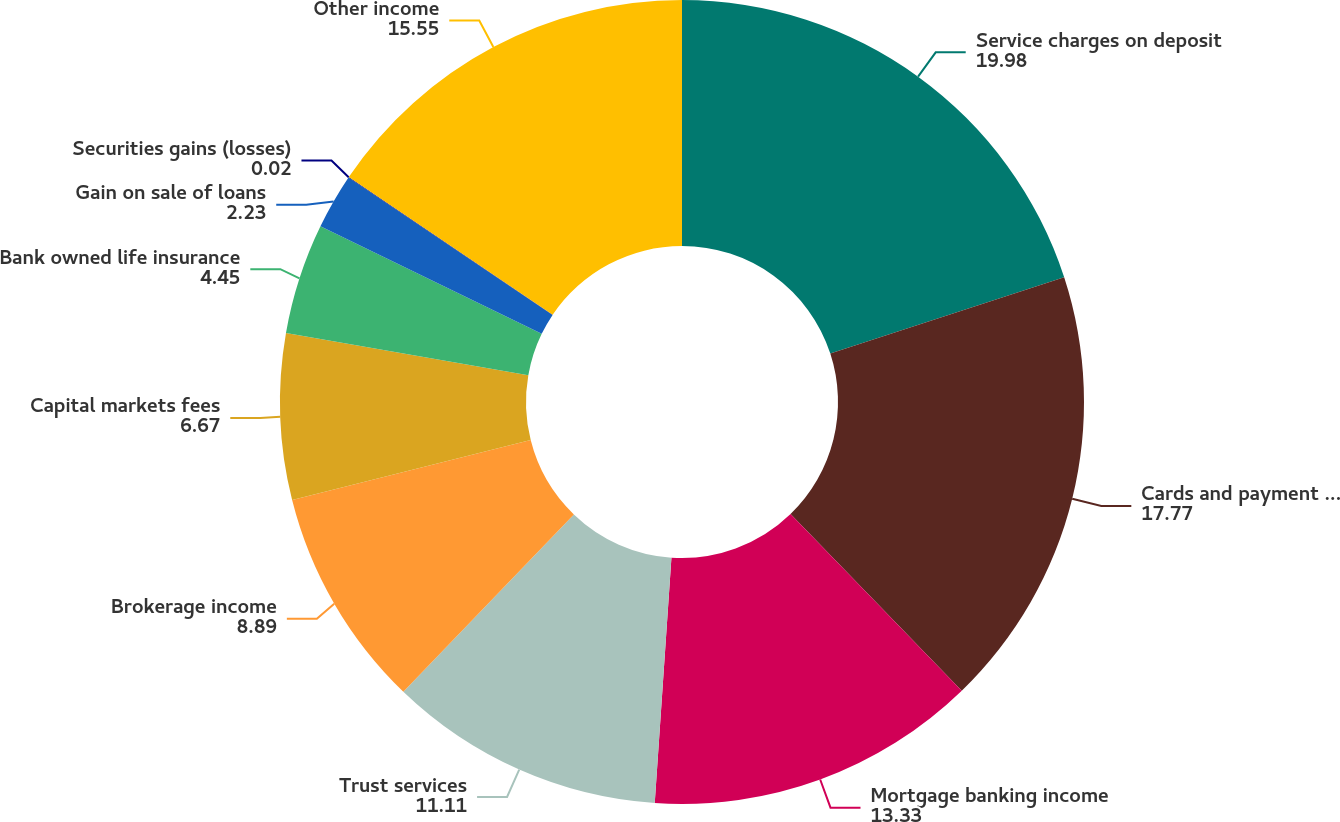Convert chart to OTSL. <chart><loc_0><loc_0><loc_500><loc_500><pie_chart><fcel>Service charges on deposit<fcel>Cards and payment processing<fcel>Mortgage banking income<fcel>Trust services<fcel>Brokerage income<fcel>Capital markets fees<fcel>Bank owned life insurance<fcel>Gain on sale of loans<fcel>Securities gains (losses)<fcel>Other income<nl><fcel>19.98%<fcel>17.77%<fcel>13.33%<fcel>11.11%<fcel>8.89%<fcel>6.67%<fcel>4.45%<fcel>2.23%<fcel>0.02%<fcel>15.55%<nl></chart> 